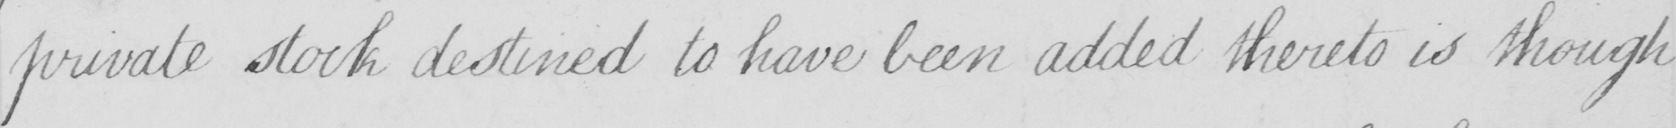Please transcribe the handwritten text in this image. private stock destined to have been added thereto is though 